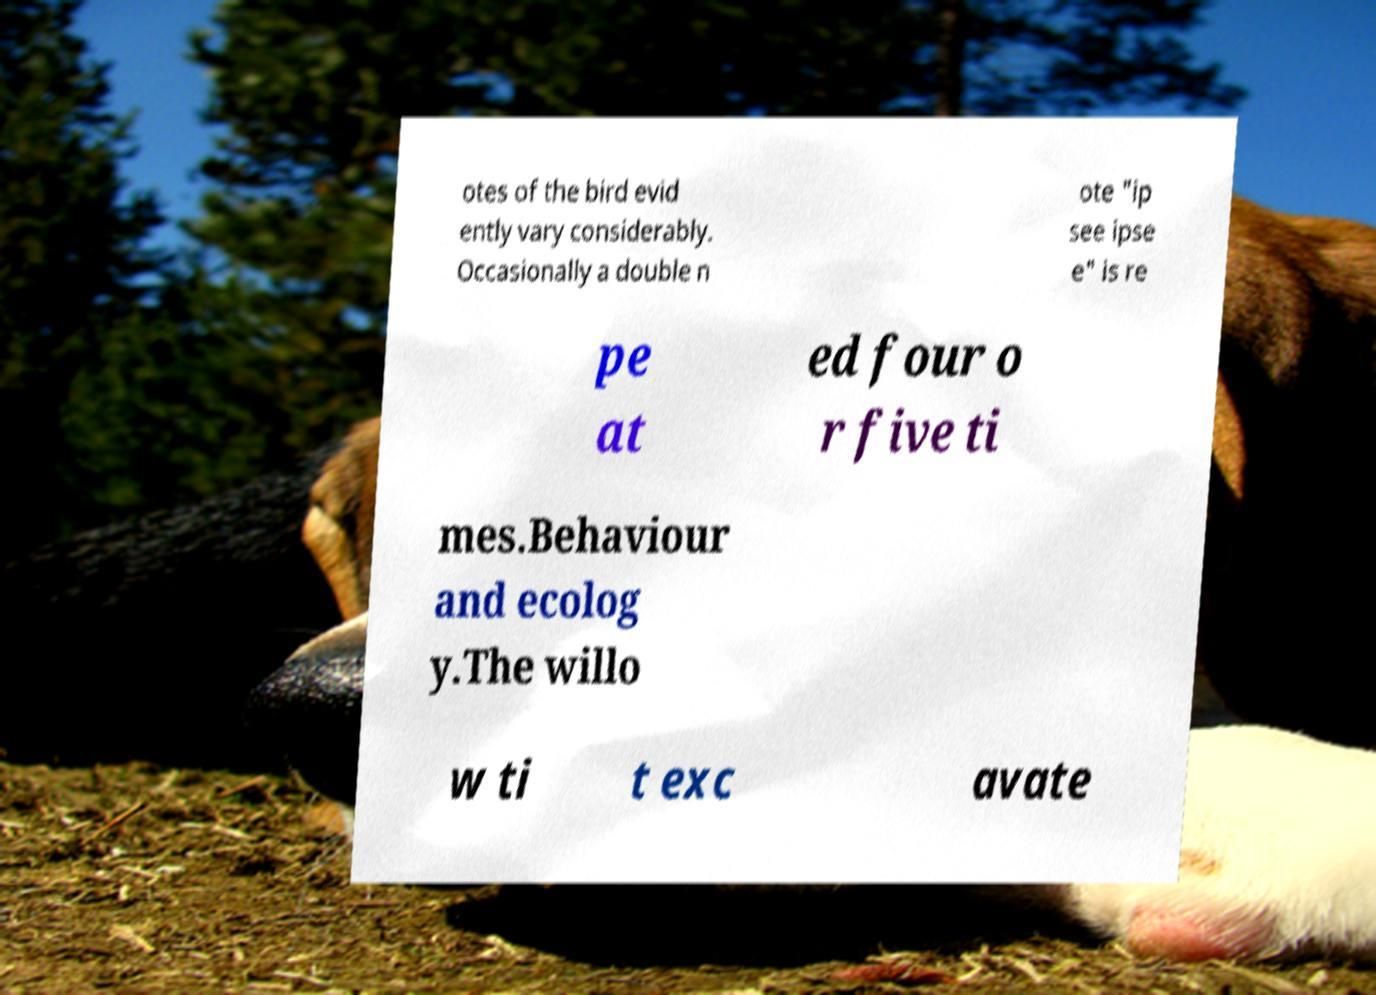For documentation purposes, I need the text within this image transcribed. Could you provide that? otes of the bird evid ently vary considerably. Occasionally a double n ote "ip see ipse e" is re pe at ed four o r five ti mes.Behaviour and ecolog y.The willo w ti t exc avate 